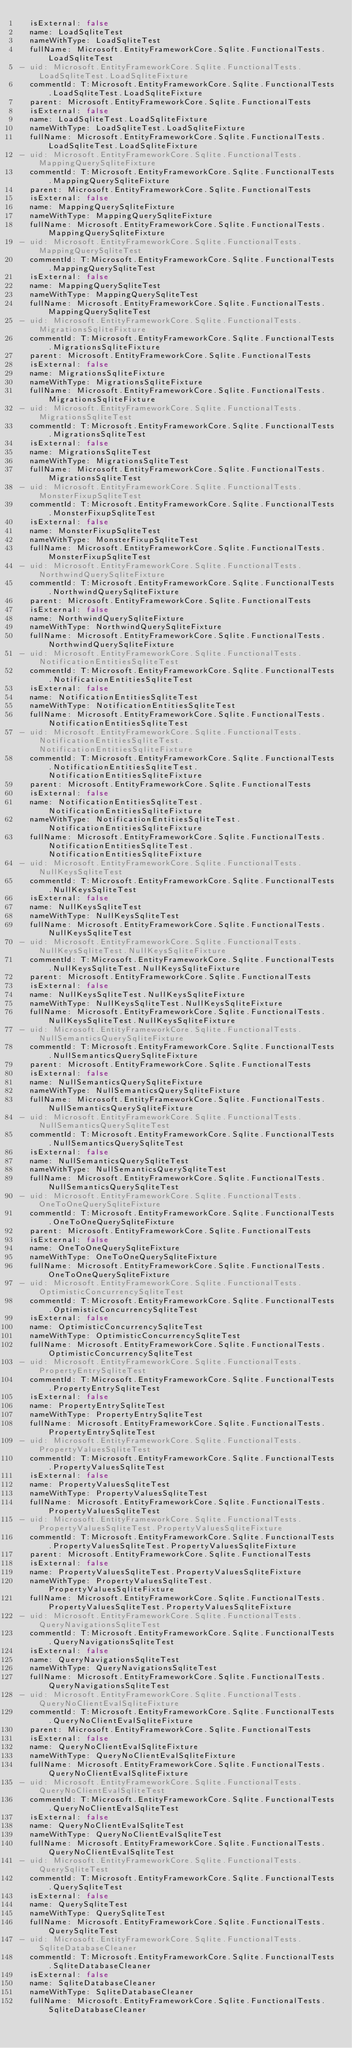<code> <loc_0><loc_0><loc_500><loc_500><_YAML_>  isExternal: false
  name: LoadSqliteTest
  nameWithType: LoadSqliteTest
  fullName: Microsoft.EntityFrameworkCore.Sqlite.FunctionalTests.LoadSqliteTest
- uid: Microsoft.EntityFrameworkCore.Sqlite.FunctionalTests.LoadSqliteTest.LoadSqliteFixture
  commentId: T:Microsoft.EntityFrameworkCore.Sqlite.FunctionalTests.LoadSqliteTest.LoadSqliteFixture
  parent: Microsoft.EntityFrameworkCore.Sqlite.FunctionalTests
  isExternal: false
  name: LoadSqliteTest.LoadSqliteFixture
  nameWithType: LoadSqliteTest.LoadSqliteFixture
  fullName: Microsoft.EntityFrameworkCore.Sqlite.FunctionalTests.LoadSqliteTest.LoadSqliteFixture
- uid: Microsoft.EntityFrameworkCore.Sqlite.FunctionalTests.MappingQuerySqliteFixture
  commentId: T:Microsoft.EntityFrameworkCore.Sqlite.FunctionalTests.MappingQuerySqliteFixture
  parent: Microsoft.EntityFrameworkCore.Sqlite.FunctionalTests
  isExternal: false
  name: MappingQuerySqliteFixture
  nameWithType: MappingQuerySqliteFixture
  fullName: Microsoft.EntityFrameworkCore.Sqlite.FunctionalTests.MappingQuerySqliteFixture
- uid: Microsoft.EntityFrameworkCore.Sqlite.FunctionalTests.MappingQuerySqliteTest
  commentId: T:Microsoft.EntityFrameworkCore.Sqlite.FunctionalTests.MappingQuerySqliteTest
  isExternal: false
  name: MappingQuerySqliteTest
  nameWithType: MappingQuerySqliteTest
  fullName: Microsoft.EntityFrameworkCore.Sqlite.FunctionalTests.MappingQuerySqliteTest
- uid: Microsoft.EntityFrameworkCore.Sqlite.FunctionalTests.MigrationsSqliteFixture
  commentId: T:Microsoft.EntityFrameworkCore.Sqlite.FunctionalTests.MigrationsSqliteFixture
  parent: Microsoft.EntityFrameworkCore.Sqlite.FunctionalTests
  isExternal: false
  name: MigrationsSqliteFixture
  nameWithType: MigrationsSqliteFixture
  fullName: Microsoft.EntityFrameworkCore.Sqlite.FunctionalTests.MigrationsSqliteFixture
- uid: Microsoft.EntityFrameworkCore.Sqlite.FunctionalTests.MigrationsSqliteTest
  commentId: T:Microsoft.EntityFrameworkCore.Sqlite.FunctionalTests.MigrationsSqliteTest
  isExternal: false
  name: MigrationsSqliteTest
  nameWithType: MigrationsSqliteTest
  fullName: Microsoft.EntityFrameworkCore.Sqlite.FunctionalTests.MigrationsSqliteTest
- uid: Microsoft.EntityFrameworkCore.Sqlite.FunctionalTests.MonsterFixupSqliteTest
  commentId: T:Microsoft.EntityFrameworkCore.Sqlite.FunctionalTests.MonsterFixupSqliteTest
  isExternal: false
  name: MonsterFixupSqliteTest
  nameWithType: MonsterFixupSqliteTest
  fullName: Microsoft.EntityFrameworkCore.Sqlite.FunctionalTests.MonsterFixupSqliteTest
- uid: Microsoft.EntityFrameworkCore.Sqlite.FunctionalTests.NorthwindQuerySqliteFixture
  commentId: T:Microsoft.EntityFrameworkCore.Sqlite.FunctionalTests.NorthwindQuerySqliteFixture
  parent: Microsoft.EntityFrameworkCore.Sqlite.FunctionalTests
  isExternal: false
  name: NorthwindQuerySqliteFixture
  nameWithType: NorthwindQuerySqliteFixture
  fullName: Microsoft.EntityFrameworkCore.Sqlite.FunctionalTests.NorthwindQuerySqliteFixture
- uid: Microsoft.EntityFrameworkCore.Sqlite.FunctionalTests.NotificationEntitiesSqliteTest
  commentId: T:Microsoft.EntityFrameworkCore.Sqlite.FunctionalTests.NotificationEntitiesSqliteTest
  isExternal: false
  name: NotificationEntitiesSqliteTest
  nameWithType: NotificationEntitiesSqliteTest
  fullName: Microsoft.EntityFrameworkCore.Sqlite.FunctionalTests.NotificationEntitiesSqliteTest
- uid: Microsoft.EntityFrameworkCore.Sqlite.FunctionalTests.NotificationEntitiesSqliteTest.NotificationEntitiesSqliteFixture
  commentId: T:Microsoft.EntityFrameworkCore.Sqlite.FunctionalTests.NotificationEntitiesSqliteTest.NotificationEntitiesSqliteFixture
  parent: Microsoft.EntityFrameworkCore.Sqlite.FunctionalTests
  isExternal: false
  name: NotificationEntitiesSqliteTest.NotificationEntitiesSqliteFixture
  nameWithType: NotificationEntitiesSqliteTest.NotificationEntitiesSqliteFixture
  fullName: Microsoft.EntityFrameworkCore.Sqlite.FunctionalTests.NotificationEntitiesSqliteTest.NotificationEntitiesSqliteFixture
- uid: Microsoft.EntityFrameworkCore.Sqlite.FunctionalTests.NullKeysSqliteTest
  commentId: T:Microsoft.EntityFrameworkCore.Sqlite.FunctionalTests.NullKeysSqliteTest
  isExternal: false
  name: NullKeysSqliteTest
  nameWithType: NullKeysSqliteTest
  fullName: Microsoft.EntityFrameworkCore.Sqlite.FunctionalTests.NullKeysSqliteTest
- uid: Microsoft.EntityFrameworkCore.Sqlite.FunctionalTests.NullKeysSqliteTest.NullKeysSqliteFixture
  commentId: T:Microsoft.EntityFrameworkCore.Sqlite.FunctionalTests.NullKeysSqliteTest.NullKeysSqliteFixture
  parent: Microsoft.EntityFrameworkCore.Sqlite.FunctionalTests
  isExternal: false
  name: NullKeysSqliteTest.NullKeysSqliteFixture
  nameWithType: NullKeysSqliteTest.NullKeysSqliteFixture
  fullName: Microsoft.EntityFrameworkCore.Sqlite.FunctionalTests.NullKeysSqliteTest.NullKeysSqliteFixture
- uid: Microsoft.EntityFrameworkCore.Sqlite.FunctionalTests.NullSemanticsQuerySqliteFixture
  commentId: T:Microsoft.EntityFrameworkCore.Sqlite.FunctionalTests.NullSemanticsQuerySqliteFixture
  parent: Microsoft.EntityFrameworkCore.Sqlite.FunctionalTests
  isExternal: false
  name: NullSemanticsQuerySqliteFixture
  nameWithType: NullSemanticsQuerySqliteFixture
  fullName: Microsoft.EntityFrameworkCore.Sqlite.FunctionalTests.NullSemanticsQuerySqliteFixture
- uid: Microsoft.EntityFrameworkCore.Sqlite.FunctionalTests.NullSemanticsQuerySqliteTest
  commentId: T:Microsoft.EntityFrameworkCore.Sqlite.FunctionalTests.NullSemanticsQuerySqliteTest
  isExternal: false
  name: NullSemanticsQuerySqliteTest
  nameWithType: NullSemanticsQuerySqliteTest
  fullName: Microsoft.EntityFrameworkCore.Sqlite.FunctionalTests.NullSemanticsQuerySqliteTest
- uid: Microsoft.EntityFrameworkCore.Sqlite.FunctionalTests.OneToOneQuerySqliteFixture
  commentId: T:Microsoft.EntityFrameworkCore.Sqlite.FunctionalTests.OneToOneQuerySqliteFixture
  parent: Microsoft.EntityFrameworkCore.Sqlite.FunctionalTests
  isExternal: false
  name: OneToOneQuerySqliteFixture
  nameWithType: OneToOneQuerySqliteFixture
  fullName: Microsoft.EntityFrameworkCore.Sqlite.FunctionalTests.OneToOneQuerySqliteFixture
- uid: Microsoft.EntityFrameworkCore.Sqlite.FunctionalTests.OptimisticConcurrencySqliteTest
  commentId: T:Microsoft.EntityFrameworkCore.Sqlite.FunctionalTests.OptimisticConcurrencySqliteTest
  isExternal: false
  name: OptimisticConcurrencySqliteTest
  nameWithType: OptimisticConcurrencySqliteTest
  fullName: Microsoft.EntityFrameworkCore.Sqlite.FunctionalTests.OptimisticConcurrencySqliteTest
- uid: Microsoft.EntityFrameworkCore.Sqlite.FunctionalTests.PropertyEntrySqliteTest
  commentId: T:Microsoft.EntityFrameworkCore.Sqlite.FunctionalTests.PropertyEntrySqliteTest
  isExternal: false
  name: PropertyEntrySqliteTest
  nameWithType: PropertyEntrySqliteTest
  fullName: Microsoft.EntityFrameworkCore.Sqlite.FunctionalTests.PropertyEntrySqliteTest
- uid: Microsoft.EntityFrameworkCore.Sqlite.FunctionalTests.PropertyValuesSqliteTest
  commentId: T:Microsoft.EntityFrameworkCore.Sqlite.FunctionalTests.PropertyValuesSqliteTest
  isExternal: false
  name: PropertyValuesSqliteTest
  nameWithType: PropertyValuesSqliteTest
  fullName: Microsoft.EntityFrameworkCore.Sqlite.FunctionalTests.PropertyValuesSqliteTest
- uid: Microsoft.EntityFrameworkCore.Sqlite.FunctionalTests.PropertyValuesSqliteTest.PropertyValuesSqliteFixture
  commentId: T:Microsoft.EntityFrameworkCore.Sqlite.FunctionalTests.PropertyValuesSqliteTest.PropertyValuesSqliteFixture
  parent: Microsoft.EntityFrameworkCore.Sqlite.FunctionalTests
  isExternal: false
  name: PropertyValuesSqliteTest.PropertyValuesSqliteFixture
  nameWithType: PropertyValuesSqliteTest.PropertyValuesSqliteFixture
  fullName: Microsoft.EntityFrameworkCore.Sqlite.FunctionalTests.PropertyValuesSqliteTest.PropertyValuesSqliteFixture
- uid: Microsoft.EntityFrameworkCore.Sqlite.FunctionalTests.QueryNavigationsSqliteTest
  commentId: T:Microsoft.EntityFrameworkCore.Sqlite.FunctionalTests.QueryNavigationsSqliteTest
  isExternal: false
  name: QueryNavigationsSqliteTest
  nameWithType: QueryNavigationsSqliteTest
  fullName: Microsoft.EntityFrameworkCore.Sqlite.FunctionalTests.QueryNavigationsSqliteTest
- uid: Microsoft.EntityFrameworkCore.Sqlite.FunctionalTests.QueryNoClientEvalSqliteFixture
  commentId: T:Microsoft.EntityFrameworkCore.Sqlite.FunctionalTests.QueryNoClientEvalSqliteFixture
  parent: Microsoft.EntityFrameworkCore.Sqlite.FunctionalTests
  isExternal: false
  name: QueryNoClientEvalSqliteFixture
  nameWithType: QueryNoClientEvalSqliteFixture
  fullName: Microsoft.EntityFrameworkCore.Sqlite.FunctionalTests.QueryNoClientEvalSqliteFixture
- uid: Microsoft.EntityFrameworkCore.Sqlite.FunctionalTests.QueryNoClientEvalSqliteTest
  commentId: T:Microsoft.EntityFrameworkCore.Sqlite.FunctionalTests.QueryNoClientEvalSqliteTest
  isExternal: false
  name: QueryNoClientEvalSqliteTest
  nameWithType: QueryNoClientEvalSqliteTest
  fullName: Microsoft.EntityFrameworkCore.Sqlite.FunctionalTests.QueryNoClientEvalSqliteTest
- uid: Microsoft.EntityFrameworkCore.Sqlite.FunctionalTests.QuerySqliteTest
  commentId: T:Microsoft.EntityFrameworkCore.Sqlite.FunctionalTests.QuerySqliteTest
  isExternal: false
  name: QuerySqliteTest
  nameWithType: QuerySqliteTest
  fullName: Microsoft.EntityFrameworkCore.Sqlite.FunctionalTests.QuerySqliteTest
- uid: Microsoft.EntityFrameworkCore.Sqlite.FunctionalTests.SqliteDatabaseCleaner
  commentId: T:Microsoft.EntityFrameworkCore.Sqlite.FunctionalTests.SqliteDatabaseCleaner
  isExternal: false
  name: SqliteDatabaseCleaner
  nameWithType: SqliteDatabaseCleaner
  fullName: Microsoft.EntityFrameworkCore.Sqlite.FunctionalTests.SqliteDatabaseCleaner</code> 